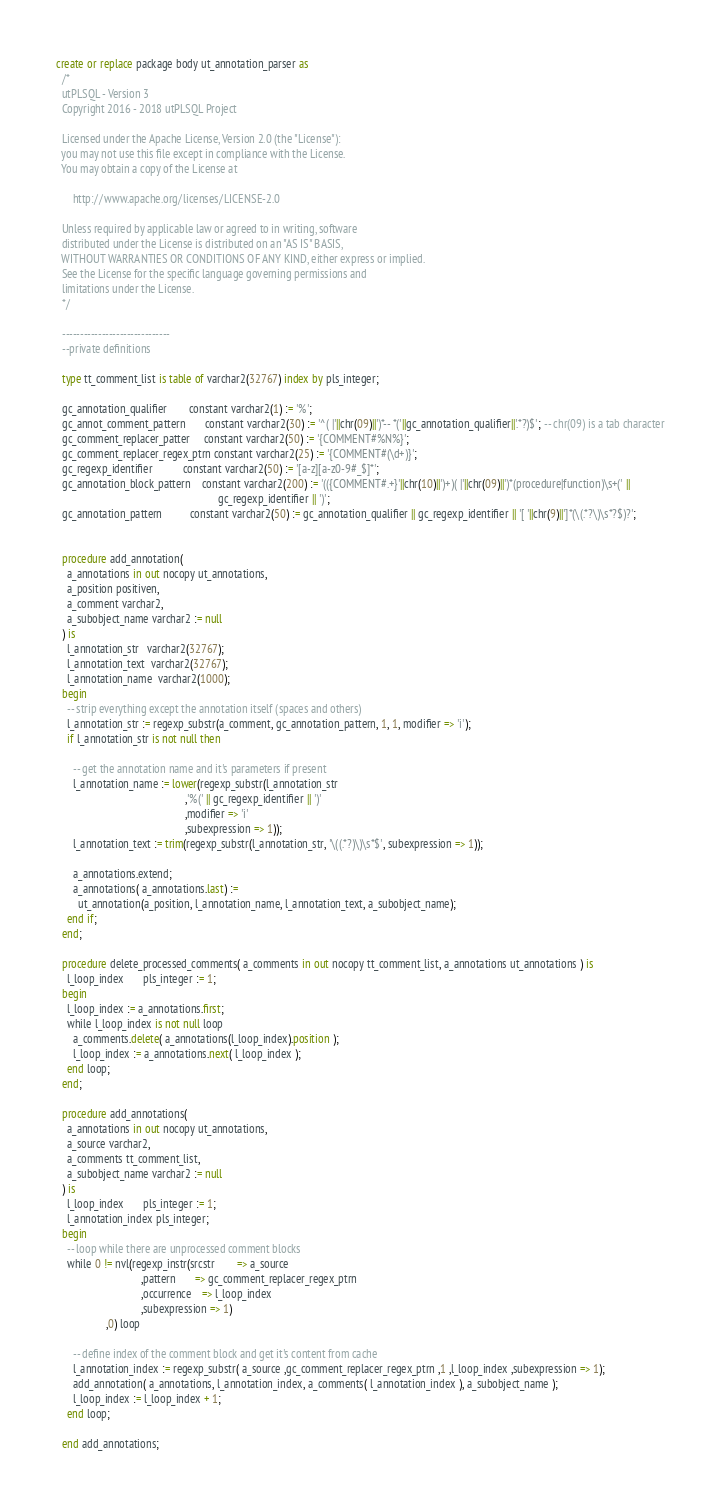<code> <loc_0><loc_0><loc_500><loc_500><_SQL_>create or replace package body ut_annotation_parser as
  /*
  utPLSQL - Version 3
  Copyright 2016 - 2018 utPLSQL Project

  Licensed under the Apache License, Version 2.0 (the "License"):
  you may not use this file except in compliance with the License.
  You may obtain a copy of the License at

      http://www.apache.org/licenses/LICENSE-2.0

  Unless required by applicable law or agreed to in writing, software
  distributed under the License is distributed on an "AS IS" BASIS,
  WITHOUT WARRANTIES OR CONDITIONS OF ANY KIND, either express or implied.
  See the License for the specific language governing permissions and
  limitations under the License.
  */

  ------------------------------
  --private definitions

  type tt_comment_list is table of varchar2(32767) index by pls_integer;

  gc_annotation_qualifier        constant varchar2(1) := '%';
  gc_annot_comment_pattern       constant varchar2(30) := '^( |'||chr(09)||')*-- *('||gc_annotation_qualifier||'.*?)$'; -- chr(09) is a tab character
  gc_comment_replacer_patter     constant varchar2(50) := '{COMMENT#%N%}';
  gc_comment_replacer_regex_ptrn constant varchar2(25) := '{COMMENT#(\d+)}';
  gc_regexp_identifier           constant varchar2(50) := '[a-z][a-z0-9#_$]*';
  gc_annotation_block_pattern    constant varchar2(200) := '(({COMMENT#.+}'||chr(10)||')+)( |'||chr(09)||')*(procedure|function)\s+(' ||
                                                           gc_regexp_identifier || ')';
  gc_annotation_pattern          constant varchar2(50) := gc_annotation_qualifier || gc_regexp_identifier || '[ '||chr(9)||']*(\(.*?\)\s*?$)?';


  procedure add_annotation(
    a_annotations in out nocopy ut_annotations,
    a_position positiven,
    a_comment varchar2,
    a_subobject_name varchar2 := null
  ) is
    l_annotation_str   varchar2(32767);
    l_annotation_text  varchar2(32767);
    l_annotation_name  varchar2(1000);
  begin
    -- strip everything except the annotation itself (spaces and others)
    l_annotation_str := regexp_substr(a_comment, gc_annotation_pattern, 1, 1, modifier => 'i');
    if l_annotation_str is not null then

      -- get the annotation name and it's parameters if present
      l_annotation_name := lower(regexp_substr(l_annotation_str
                                               ,'%(' || gc_regexp_identifier || ')'
                                               ,modifier => 'i'
                                               ,subexpression => 1));
      l_annotation_text := trim(regexp_substr(l_annotation_str, '\((.*?)\)\s*$', subexpression => 1));

      a_annotations.extend;
      a_annotations( a_annotations.last) :=
        ut_annotation(a_position, l_annotation_name, l_annotation_text, a_subobject_name);
    end if;
  end;

  procedure delete_processed_comments( a_comments in out nocopy tt_comment_list, a_annotations ut_annotations ) is
    l_loop_index       pls_integer := 1;
  begin
    l_loop_index := a_annotations.first;
    while l_loop_index is not null loop
      a_comments.delete( a_annotations(l_loop_index).position );
      l_loop_index := a_annotations.next( l_loop_index );
    end loop;
  end;

  procedure add_annotations(
    a_annotations in out nocopy ut_annotations,
    a_source varchar2,
    a_comments tt_comment_list,
    a_subobject_name varchar2 := null
  ) is
    l_loop_index       pls_integer := 1;
    l_annotation_index pls_integer;
  begin
    -- loop while there are unprocessed comment blocks
    while 0 != nvl(regexp_instr(srcstr        => a_source
                               ,pattern       => gc_comment_replacer_regex_ptrn
                               ,occurrence    => l_loop_index
                               ,subexpression => 1)
                  ,0) loop

      -- define index of the comment block and get it's content from cache
      l_annotation_index := regexp_substr( a_source ,gc_comment_replacer_regex_ptrn ,1 ,l_loop_index ,subexpression => 1);
      add_annotation( a_annotations, l_annotation_index, a_comments( l_annotation_index ), a_subobject_name );
      l_loop_index := l_loop_index + 1;
    end loop;

  end add_annotations;
</code> 